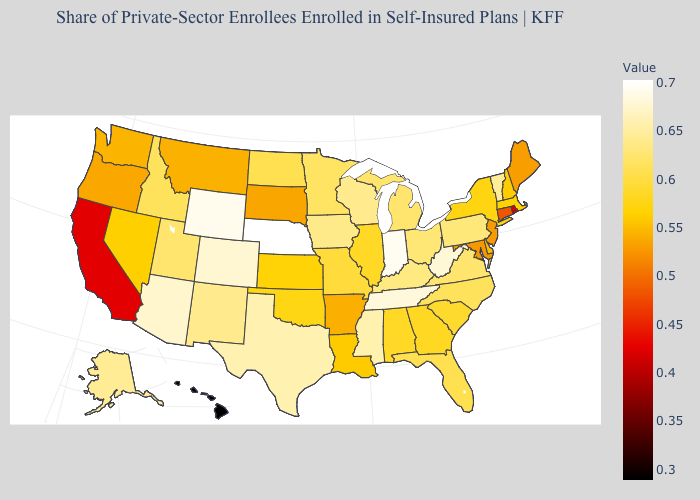Which states have the lowest value in the USA?
Quick response, please. Hawaii. Among the states that border Ohio , does West Virginia have the lowest value?
Give a very brief answer. No. Does Oklahoma have a lower value than Minnesota?
Write a very short answer. Yes. Which states hav the highest value in the MidWest?
Concise answer only. Nebraska. Does Arizona have the highest value in the USA?
Give a very brief answer. No. Among the states that border Kansas , which have the lowest value?
Give a very brief answer. Oklahoma. Does the map have missing data?
Quick response, please. No. 